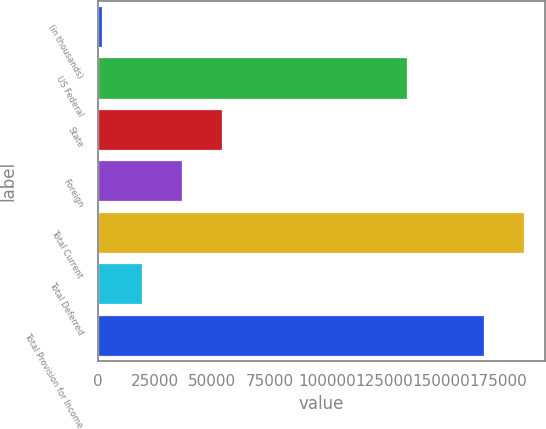Convert chart to OTSL. <chart><loc_0><loc_0><loc_500><loc_500><bar_chart><fcel>(in thousands)<fcel>US Federal<fcel>State<fcel>Foreign<fcel>Total Current<fcel>Total Deferred<fcel>Total Provision for Income<nl><fcel>2018<fcel>134869<fcel>54255.5<fcel>36843<fcel>186114<fcel>19430.5<fcel>168702<nl></chart> 